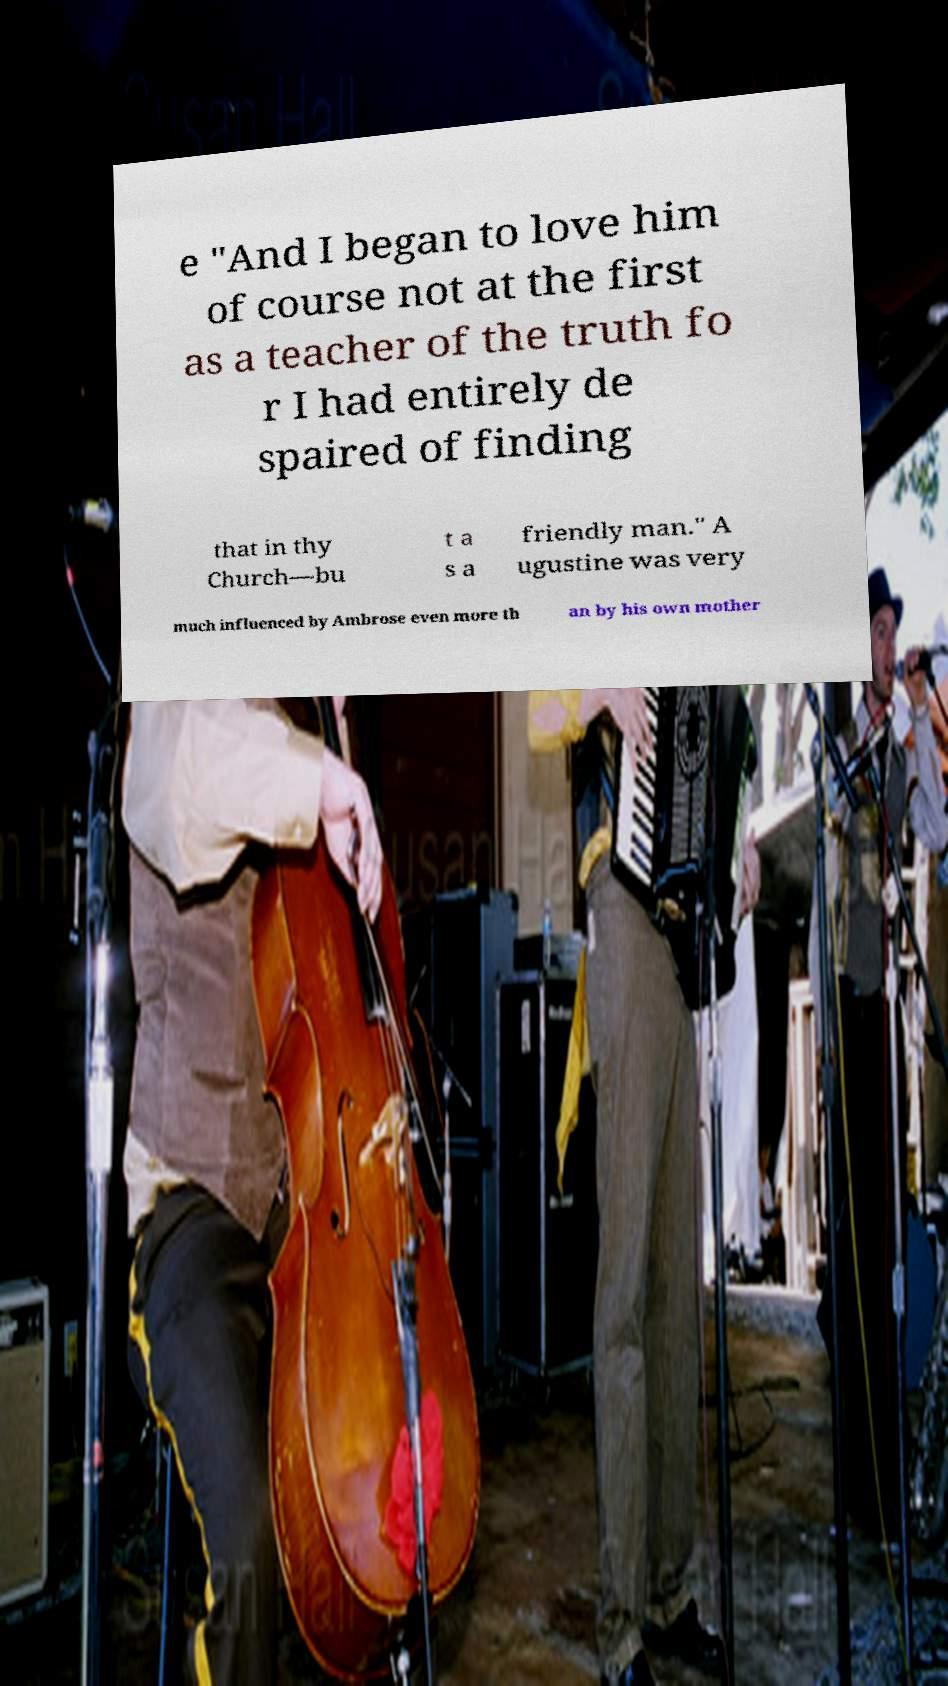Could you extract and type out the text from this image? e "And I began to love him of course not at the first as a teacher of the truth fo r I had entirely de spaired of finding that in thy Church—bu t a s a friendly man." A ugustine was very much influenced by Ambrose even more th an by his own mother 